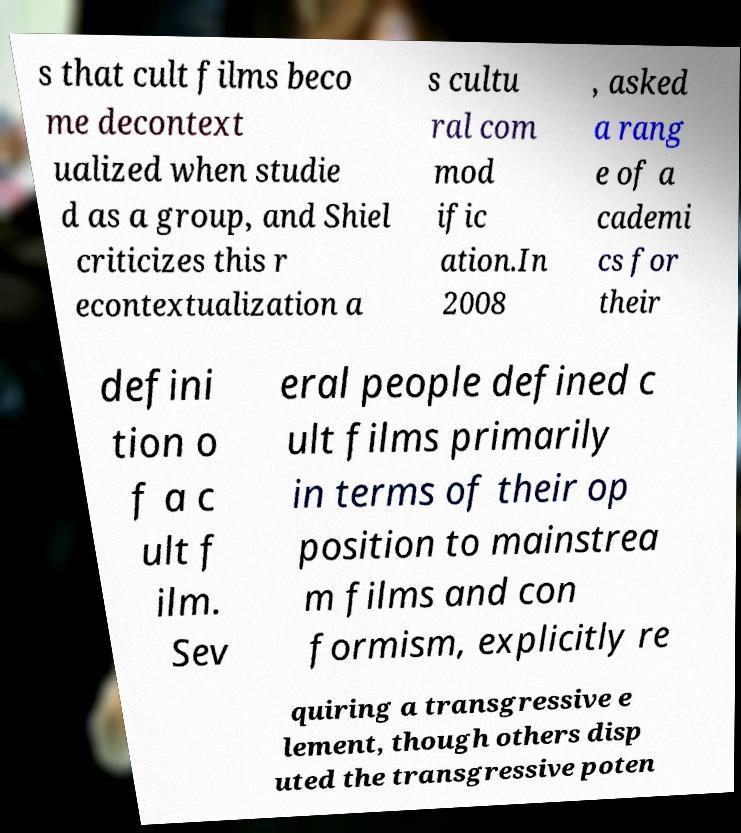Can you read and provide the text displayed in the image?This photo seems to have some interesting text. Can you extract and type it out for me? s that cult films beco me decontext ualized when studie d as a group, and Shiel criticizes this r econtextualization a s cultu ral com mod ific ation.In 2008 , asked a rang e of a cademi cs for their defini tion o f a c ult f ilm. Sev eral people defined c ult films primarily in terms of their op position to mainstrea m films and con formism, explicitly re quiring a transgressive e lement, though others disp uted the transgressive poten 